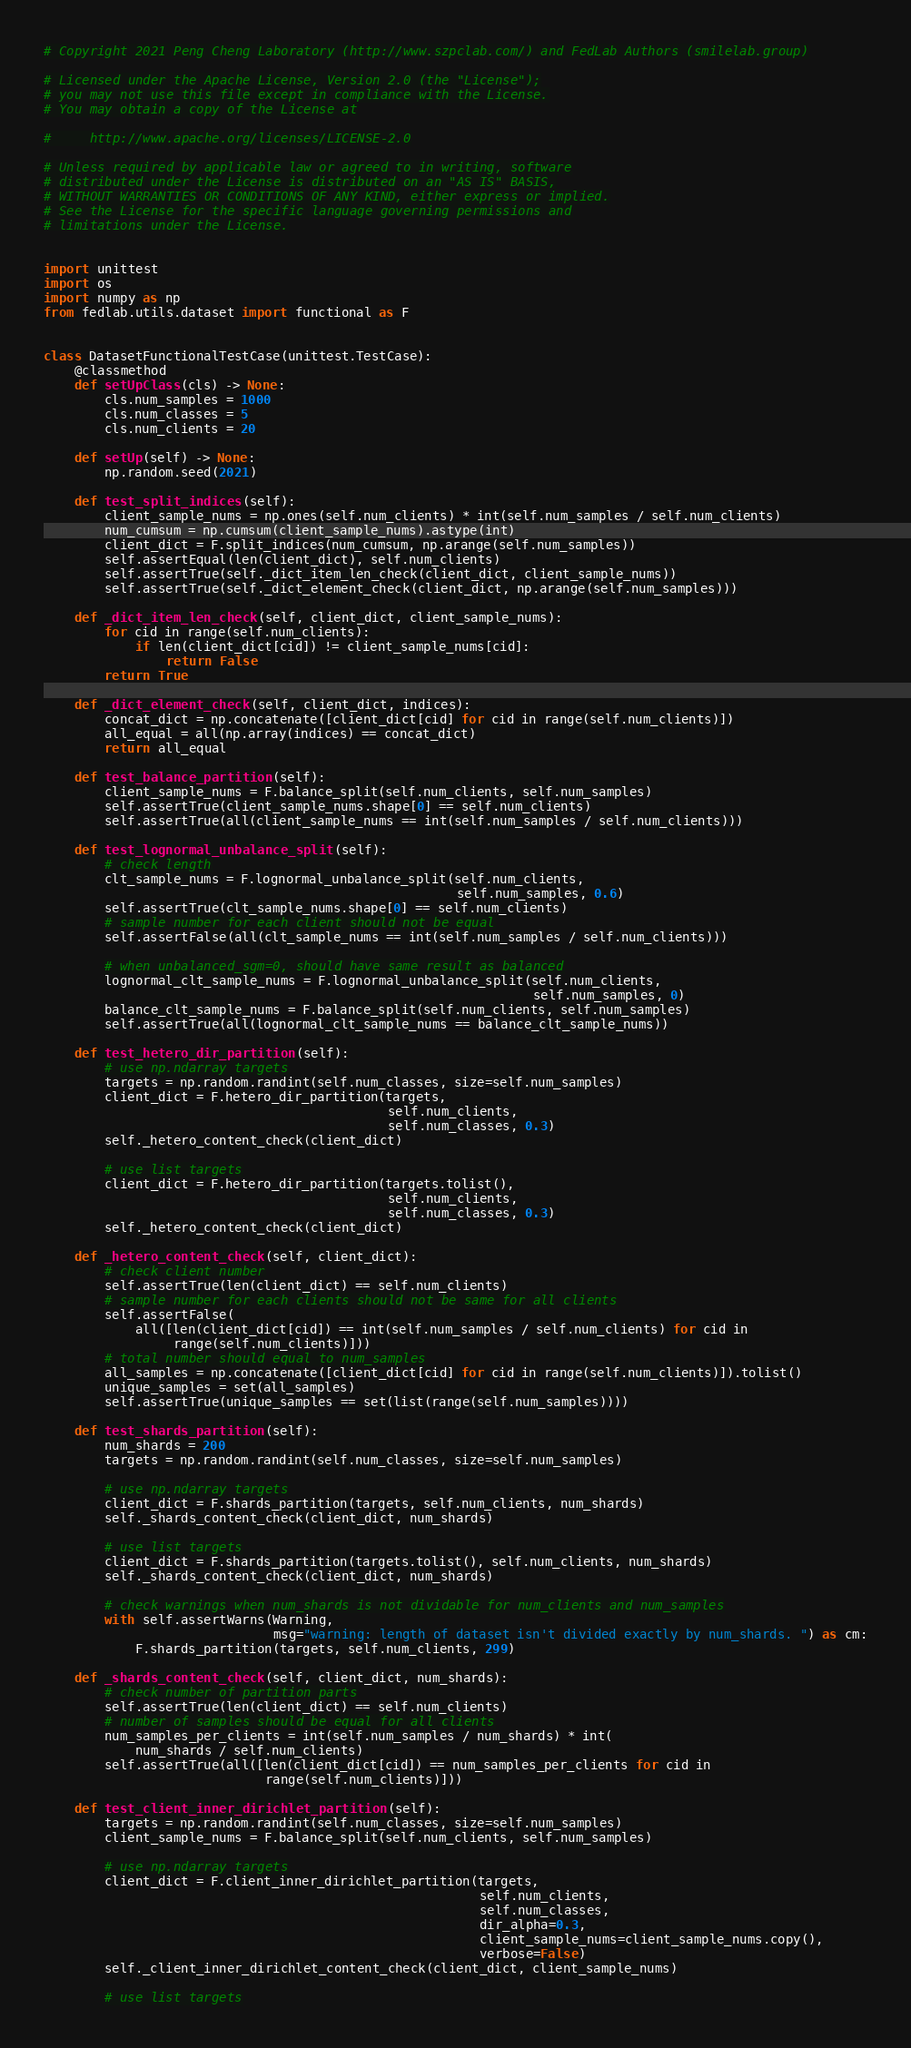Convert code to text. <code><loc_0><loc_0><loc_500><loc_500><_Python_># Copyright 2021 Peng Cheng Laboratory (http://www.szpclab.com/) and FedLab Authors (smilelab.group)

# Licensed under the Apache License, Version 2.0 (the "License");
# you may not use this file except in compliance with the License.
# You may obtain a copy of the License at

#     http://www.apache.org/licenses/LICENSE-2.0

# Unless required by applicable law or agreed to in writing, software
# distributed under the License is distributed on an "AS IS" BASIS,
# WITHOUT WARRANTIES OR CONDITIONS OF ANY KIND, either express or implied.
# See the License for the specific language governing permissions and
# limitations under the License.


import unittest
import os
import numpy as np
from fedlab.utils.dataset import functional as F


class DatasetFunctionalTestCase(unittest.TestCase):
    @classmethod
    def setUpClass(cls) -> None:
        cls.num_samples = 1000
        cls.num_classes = 5
        cls.num_clients = 20

    def setUp(self) -> None:
        np.random.seed(2021)

    def test_split_indices(self):
        client_sample_nums = np.ones(self.num_clients) * int(self.num_samples / self.num_clients)
        num_cumsum = np.cumsum(client_sample_nums).astype(int)
        client_dict = F.split_indices(num_cumsum, np.arange(self.num_samples))
        self.assertEqual(len(client_dict), self.num_clients)
        self.assertTrue(self._dict_item_len_check(client_dict, client_sample_nums))
        self.assertTrue(self._dict_element_check(client_dict, np.arange(self.num_samples)))

    def _dict_item_len_check(self, client_dict, client_sample_nums):
        for cid in range(self.num_clients):
            if len(client_dict[cid]) != client_sample_nums[cid]:
                return False
        return True

    def _dict_element_check(self, client_dict, indices):
        concat_dict = np.concatenate([client_dict[cid] for cid in range(self.num_clients)])
        all_equal = all(np.array(indices) == concat_dict)
        return all_equal

    def test_balance_partition(self):
        client_sample_nums = F.balance_split(self.num_clients, self.num_samples)
        self.assertTrue(client_sample_nums.shape[0] == self.num_clients)
        self.assertTrue(all(client_sample_nums == int(self.num_samples / self.num_clients)))

    def test_lognormal_unbalance_split(self):
        # check length
        clt_sample_nums = F.lognormal_unbalance_split(self.num_clients,
                                                      self.num_samples, 0.6)
        self.assertTrue(clt_sample_nums.shape[0] == self.num_clients)
        # sample number for each client should not be equal
        self.assertFalse(all(clt_sample_nums == int(self.num_samples / self.num_clients)))

        # when unbalanced_sgm=0, should have same result as balanced
        lognormal_clt_sample_nums = F.lognormal_unbalance_split(self.num_clients,
                                                                self.num_samples, 0)
        balance_clt_sample_nums = F.balance_split(self.num_clients, self.num_samples)
        self.assertTrue(all(lognormal_clt_sample_nums == balance_clt_sample_nums))

    def test_hetero_dir_partition(self):
        # use np.ndarray targets
        targets = np.random.randint(self.num_classes, size=self.num_samples)
        client_dict = F.hetero_dir_partition(targets,
                                             self.num_clients,
                                             self.num_classes, 0.3)
        self._hetero_content_check(client_dict)

        # use list targets
        client_dict = F.hetero_dir_partition(targets.tolist(),
                                             self.num_clients,
                                             self.num_classes, 0.3)
        self._hetero_content_check(client_dict)

    def _hetero_content_check(self, client_dict):
        # check client number
        self.assertTrue(len(client_dict) == self.num_clients)
        # sample number for each clients should not be same for all clients
        self.assertFalse(
            all([len(client_dict[cid]) == int(self.num_samples / self.num_clients) for cid in
                 range(self.num_clients)]))
        # total number should equal to num_samples
        all_samples = np.concatenate([client_dict[cid] for cid in range(self.num_clients)]).tolist()
        unique_samples = set(all_samples)
        self.assertTrue(unique_samples == set(list(range(self.num_samples))))

    def test_shards_partition(self):
        num_shards = 200
        targets = np.random.randint(self.num_classes, size=self.num_samples)

        # use np.ndarray targets
        client_dict = F.shards_partition(targets, self.num_clients, num_shards)
        self._shards_content_check(client_dict, num_shards)

        # use list targets
        client_dict = F.shards_partition(targets.tolist(), self.num_clients, num_shards)
        self._shards_content_check(client_dict, num_shards)

        # check warnings when num_shards is not dividable for num_clients and num_samples
        with self.assertWarns(Warning,
                              msg="warning: length of dataset isn't divided exactly by num_shards. ") as cm:
            F.shards_partition(targets, self.num_clients, 299)

    def _shards_content_check(self, client_dict, num_shards):
        # check number of partition parts
        self.assertTrue(len(client_dict) == self.num_clients)
        # number of samples should be equal for all clients
        num_samples_per_clients = int(self.num_samples / num_shards) * int(
            num_shards / self.num_clients)
        self.assertTrue(all([len(client_dict[cid]) == num_samples_per_clients for cid in
                             range(self.num_clients)]))

    def test_client_inner_dirichlet_partition(self):
        targets = np.random.randint(self.num_classes, size=self.num_samples)
        client_sample_nums = F.balance_split(self.num_clients, self.num_samples)

        # use np.ndarray targets
        client_dict = F.client_inner_dirichlet_partition(targets,
                                                         self.num_clients,
                                                         self.num_classes,
                                                         dir_alpha=0.3,
                                                         client_sample_nums=client_sample_nums.copy(),
                                                         verbose=False)
        self._client_inner_dirichlet_content_check(client_dict, client_sample_nums)

        # use list targets</code> 